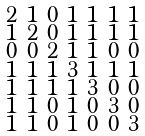Convert formula to latex. <formula><loc_0><loc_0><loc_500><loc_500>\begin{smallmatrix} 2 & 1 & 0 & 1 & 1 & 1 & 1 \\ 1 & 2 & 0 & 1 & 1 & 1 & 1 \\ 0 & 0 & 2 & 1 & 1 & 0 & 0 \\ 1 & 1 & 1 & 3 & 1 & 1 & 1 \\ 1 & 1 & 1 & 1 & 3 & 0 & 0 \\ 1 & 1 & 0 & 1 & 0 & 3 & 0 \\ 1 & 1 & 0 & 1 & 0 & 0 & 3 \end{smallmatrix}</formula> 